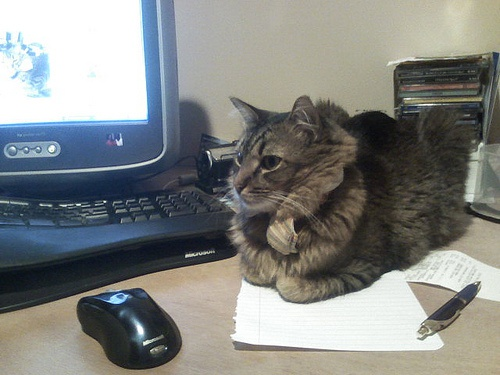Describe the objects in this image and their specific colors. I can see cat in white, black, and gray tones, tv in white, gray, navy, and blue tones, keyboard in white, black, navy, blue, and gray tones, mouse in white, black, gray, navy, and blue tones, and tie in white, gray, and tan tones in this image. 